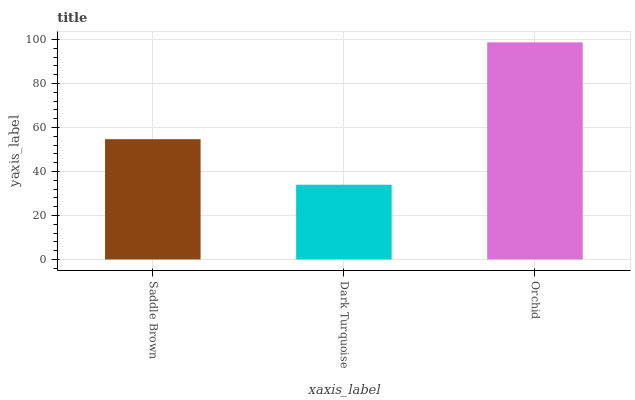Is Dark Turquoise the minimum?
Answer yes or no. Yes. Is Orchid the maximum?
Answer yes or no. Yes. Is Orchid the minimum?
Answer yes or no. No. Is Dark Turquoise the maximum?
Answer yes or no. No. Is Orchid greater than Dark Turquoise?
Answer yes or no. Yes. Is Dark Turquoise less than Orchid?
Answer yes or no. Yes. Is Dark Turquoise greater than Orchid?
Answer yes or no. No. Is Orchid less than Dark Turquoise?
Answer yes or no. No. Is Saddle Brown the high median?
Answer yes or no. Yes. Is Saddle Brown the low median?
Answer yes or no. Yes. Is Orchid the high median?
Answer yes or no. No. Is Orchid the low median?
Answer yes or no. No. 